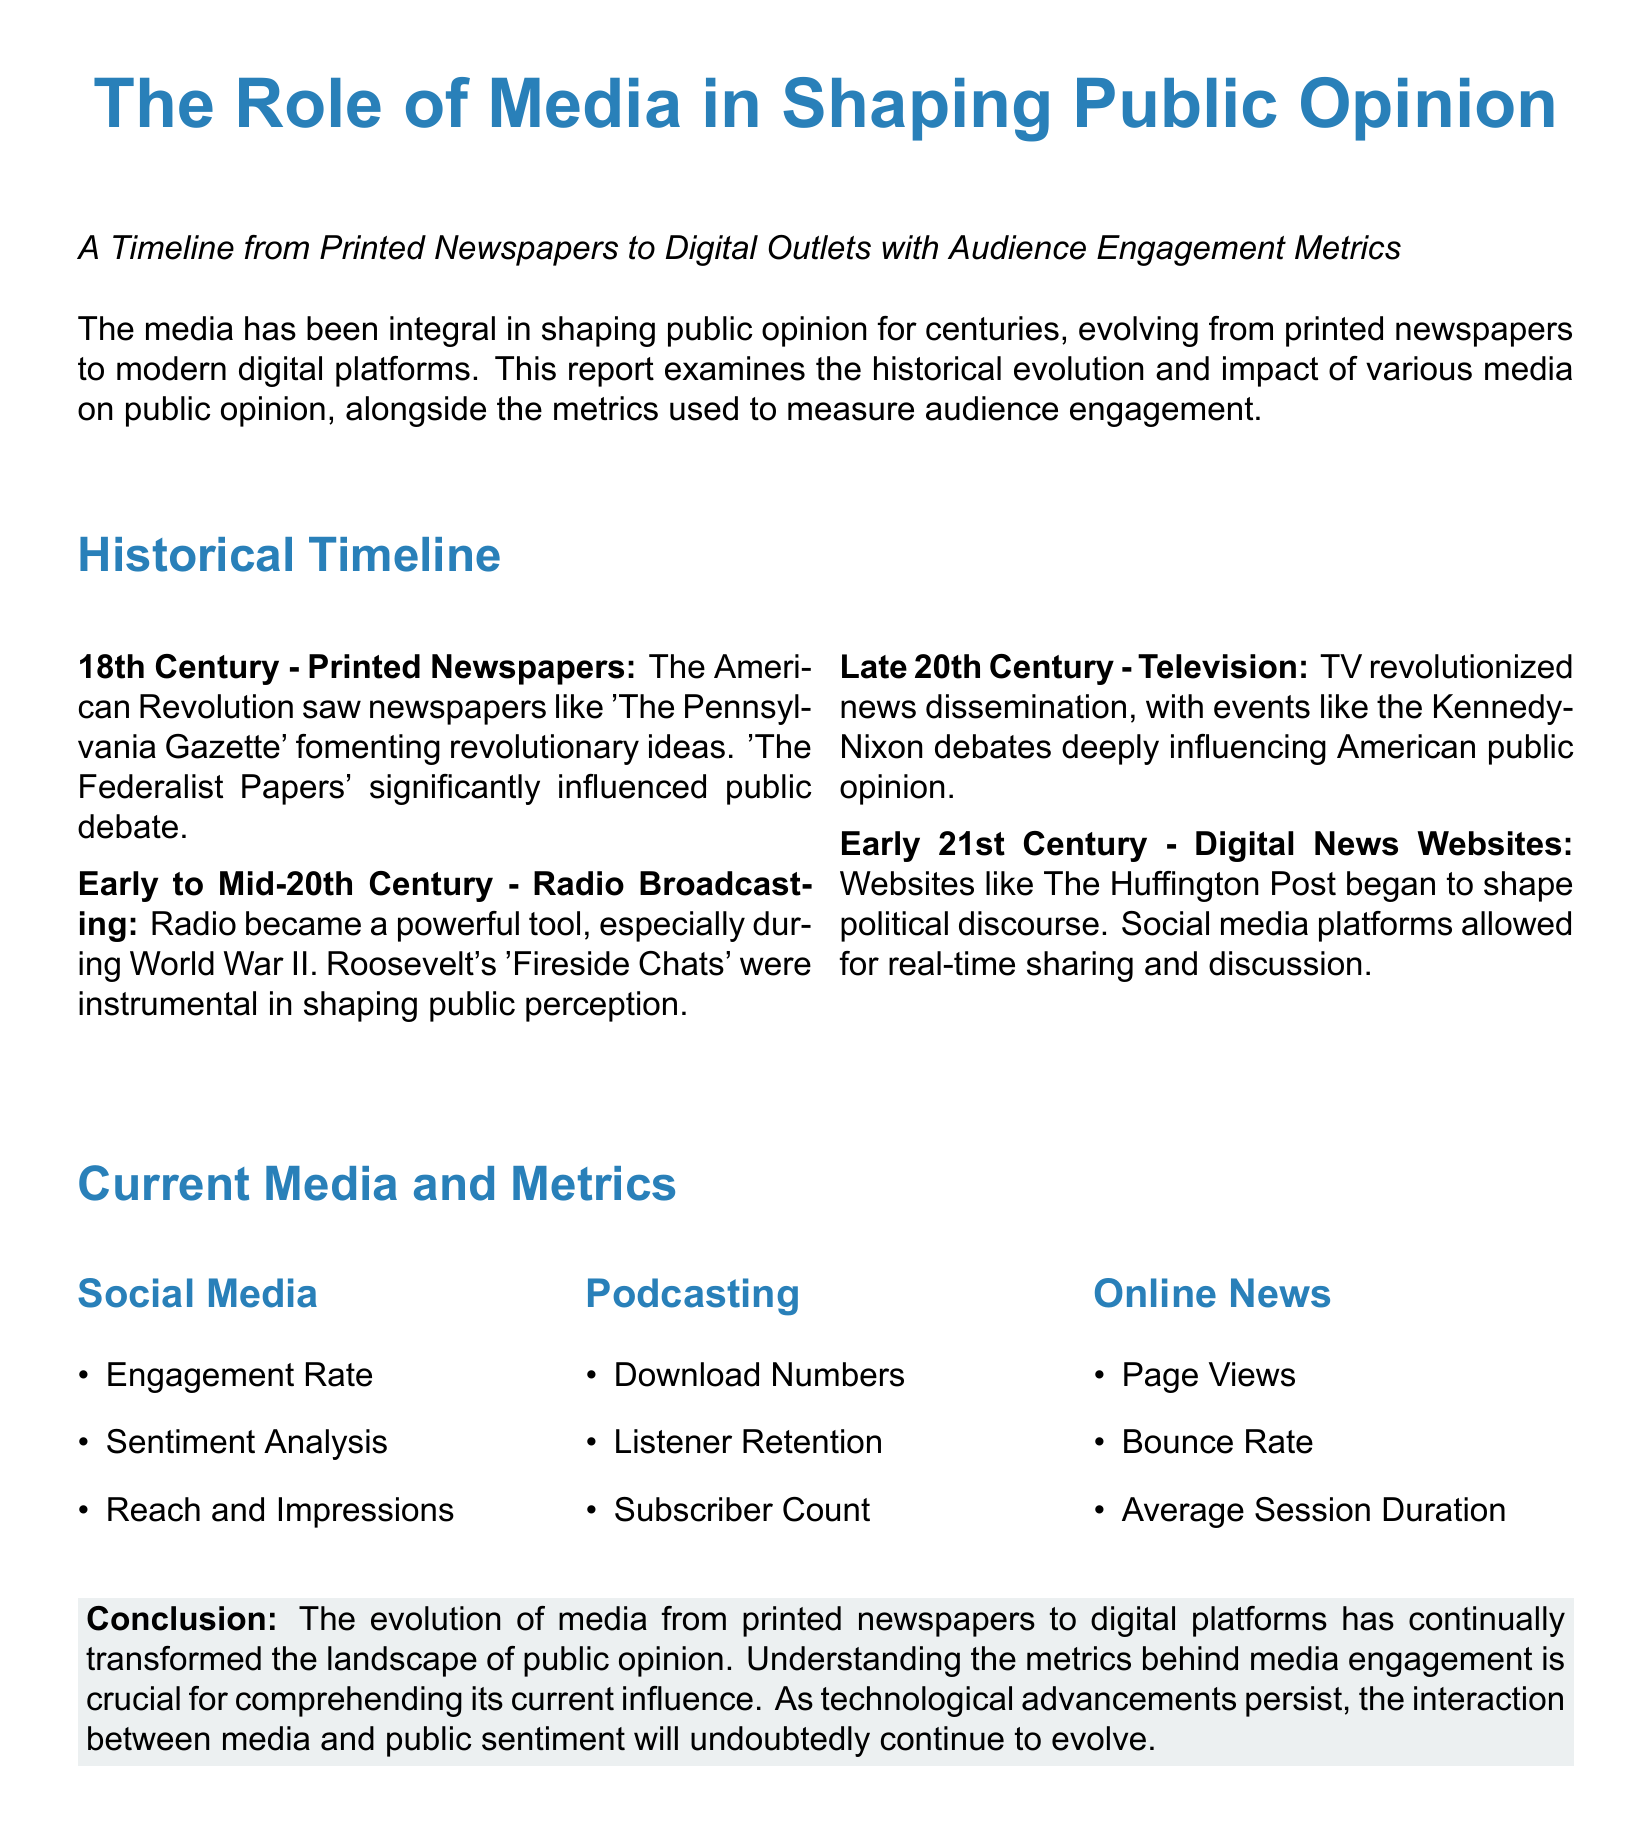What was the title of a prominent newspaper during the American Revolution? The document mentions 'The Pennsylvania Gazette' as a significant newspaper during the American Revolution.
Answer: The Pennsylvania Gazette During which event did Roosevelt give his 'Fireside Chats'? The document states that these chats were significant during World War II.
Answer: World War II What technology revolutionized news dissemination in the late 20th century? The document indicates that television was the technology that changed how news was shared.
Answer: Television What are two engagement metrics listed under Social Media? The document lists Engagement Rate and Sentiment Analysis as metrics for Social Media.
Answer: Engagement Rate, Sentiment Analysis In what century did printed newspapers begin to shape public opinion? The document specifies that printed newspapers played a role in the 18th Century.
Answer: 18th Century What is one metric associated with podcasting? The document highlights Download Numbers as a key metric related to podcasting.
Answer: Download Numbers What does the conclusion of the report emphasize about media evolution? The conclusion emphasizes the ongoing transformation of public opinion due to the evolution of media.
Answer: Transformation of public opinion Which media type allows for real-time sharing and discussion? According to the document, social media platforms enable real-time interactions.
Answer: Social Media What was a significant event that influenced American public opinion through television? The Kennedy-Nixon debates are cited as a major televised event impacting public opinion.
Answer: Kennedy-Nixon debates 